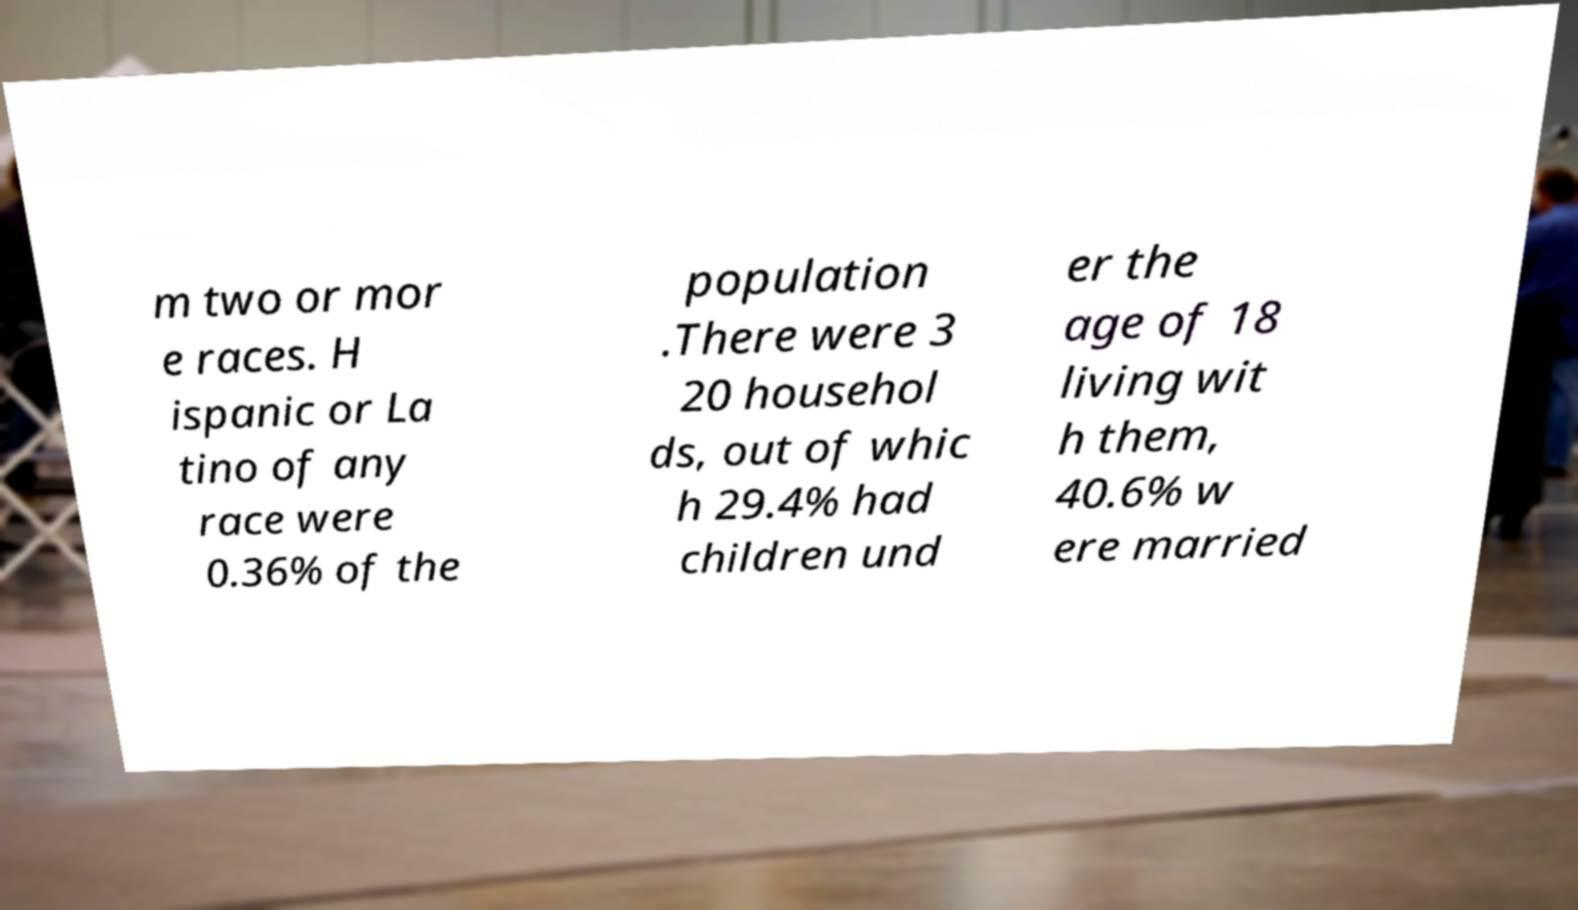For documentation purposes, I need the text within this image transcribed. Could you provide that? m two or mor e races. H ispanic or La tino of any race were 0.36% of the population .There were 3 20 househol ds, out of whic h 29.4% had children und er the age of 18 living wit h them, 40.6% w ere married 